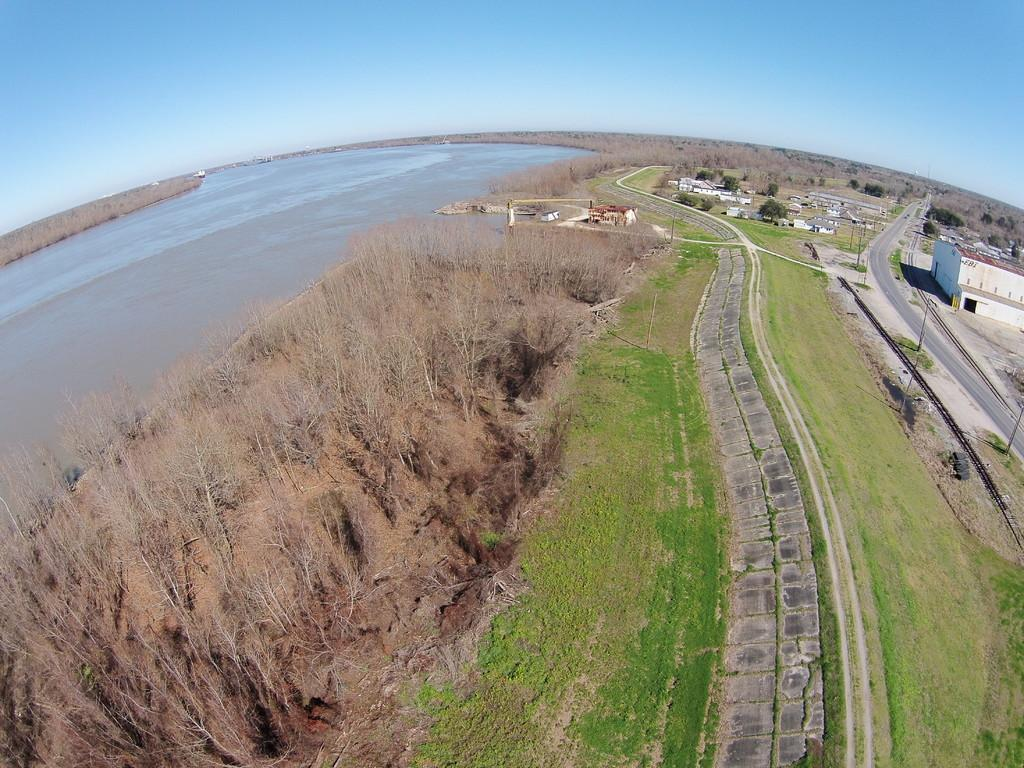What type of structures can be seen in the image? There are houses in the image. What else is present in the image besides houses? There are poles, dry trees, water, and a road in the image. What is the color of the sky in the image? The sky is a combination of white and blue colors in the image. What type of protest is happening near the houses in the image? There is no protest visible in the image; it only shows houses, poles, dry trees, water, a road, and the sky. Can you tell me which key is used to open the door of the house in the image? There is no visible door or key in the image, as it only shows the exterior of the houses. 